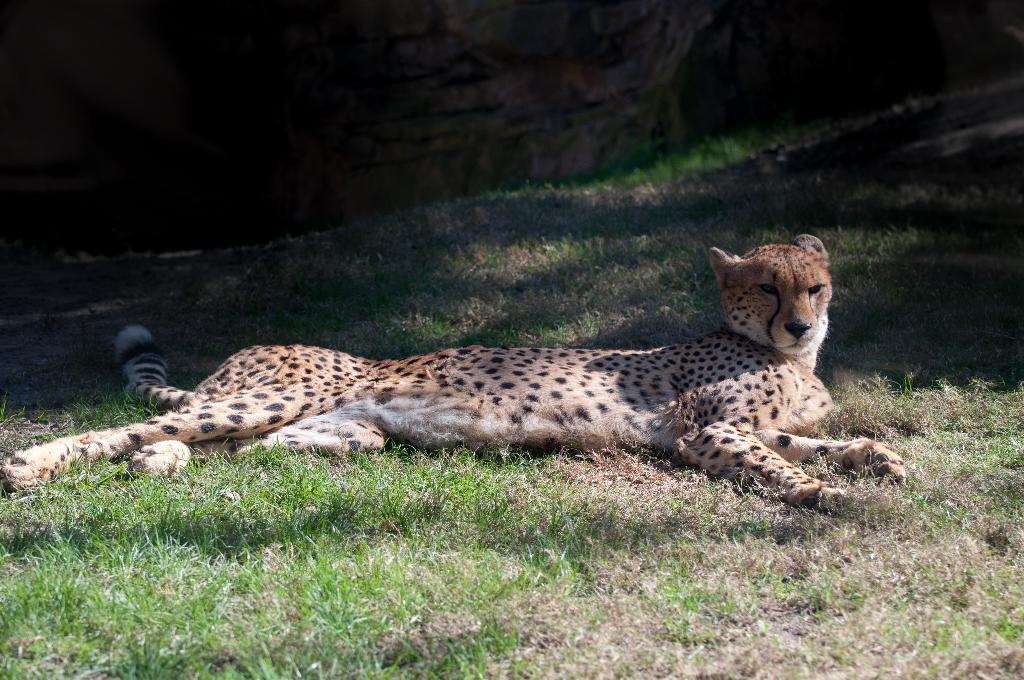Could you give a brief overview of what you see in this image? In this image there is a cheetah which is sleeping on the ground. 